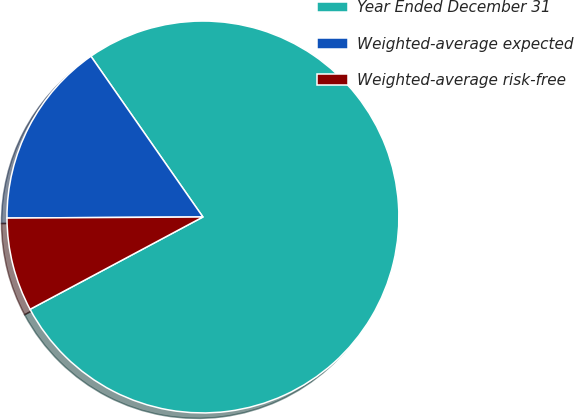<chart> <loc_0><loc_0><loc_500><loc_500><pie_chart><fcel>Year Ended December 31<fcel>Weighted-average expected<fcel>Weighted-average risk-free<nl><fcel>76.87%<fcel>15.4%<fcel>7.72%<nl></chart> 